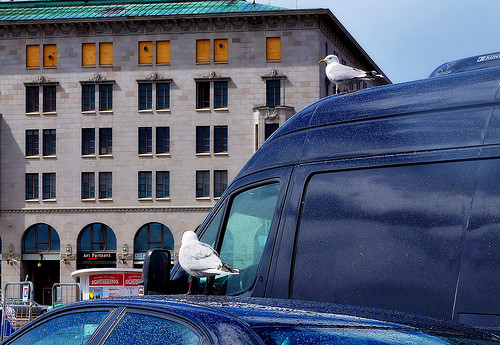<image>
Can you confirm if the seagull is on the building? No. The seagull is not positioned on the building. They may be near each other, but the seagull is not supported by or resting on top of the building. 